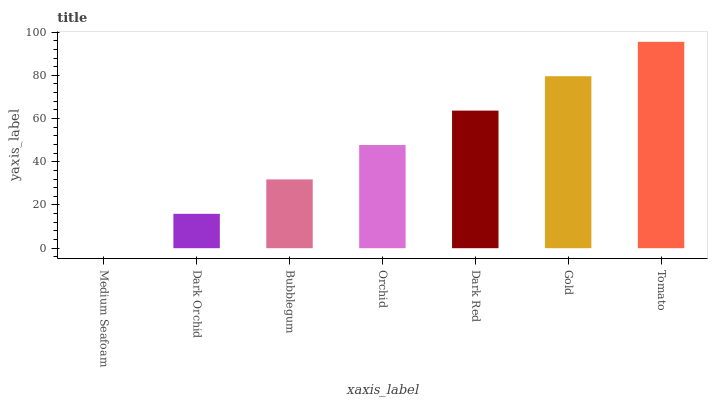Is Medium Seafoam the minimum?
Answer yes or no. Yes. Is Tomato the maximum?
Answer yes or no. Yes. Is Dark Orchid the minimum?
Answer yes or no. No. Is Dark Orchid the maximum?
Answer yes or no. No. Is Dark Orchid greater than Medium Seafoam?
Answer yes or no. Yes. Is Medium Seafoam less than Dark Orchid?
Answer yes or no. Yes. Is Medium Seafoam greater than Dark Orchid?
Answer yes or no. No. Is Dark Orchid less than Medium Seafoam?
Answer yes or no. No. Is Orchid the high median?
Answer yes or no. Yes. Is Orchid the low median?
Answer yes or no. Yes. Is Medium Seafoam the high median?
Answer yes or no. No. Is Dark Orchid the low median?
Answer yes or no. No. 